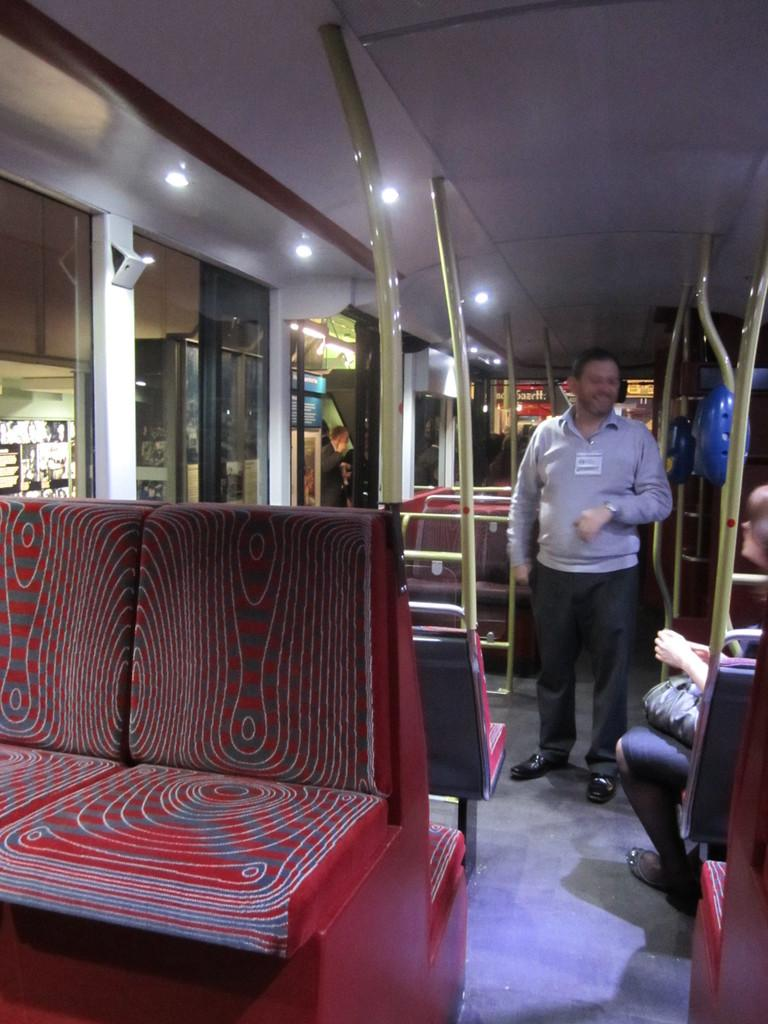What type of setting is shown in the image? The image depicts the interior of a vehicle. Are there any people present in the image? Yes, there is a person standing in the vehicle and a woman sitting in the vehicle. What type of game is being played by the person standing in the image? There is no game being played in the image; it depicts the interior of a vehicle with a person standing and a woman sitting. 